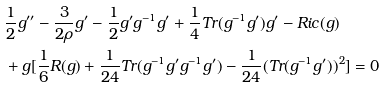<formula> <loc_0><loc_0><loc_500><loc_500>& \frac { 1 } { 2 } g ^ { \prime \prime } - \frac { 3 } { 2 \rho } g ^ { \prime } - \frac { 1 } { 2 } g ^ { \prime } g ^ { - 1 } g ^ { \prime } + \frac { 1 } { 4 } T r ( g ^ { - 1 } g ^ { \prime } ) g ^ { \prime } - R i c ( g ) \\ & + g [ \frac { 1 } { 6 } R ( g ) + \frac { 1 } { 2 4 } T r ( g ^ { - 1 } g ^ { \prime } g ^ { - 1 } g ^ { \prime } ) - \frac { 1 } { 2 4 } ( T r ( g ^ { - 1 } g ^ { \prime } ) ) ^ { 2 } ] = 0</formula> 